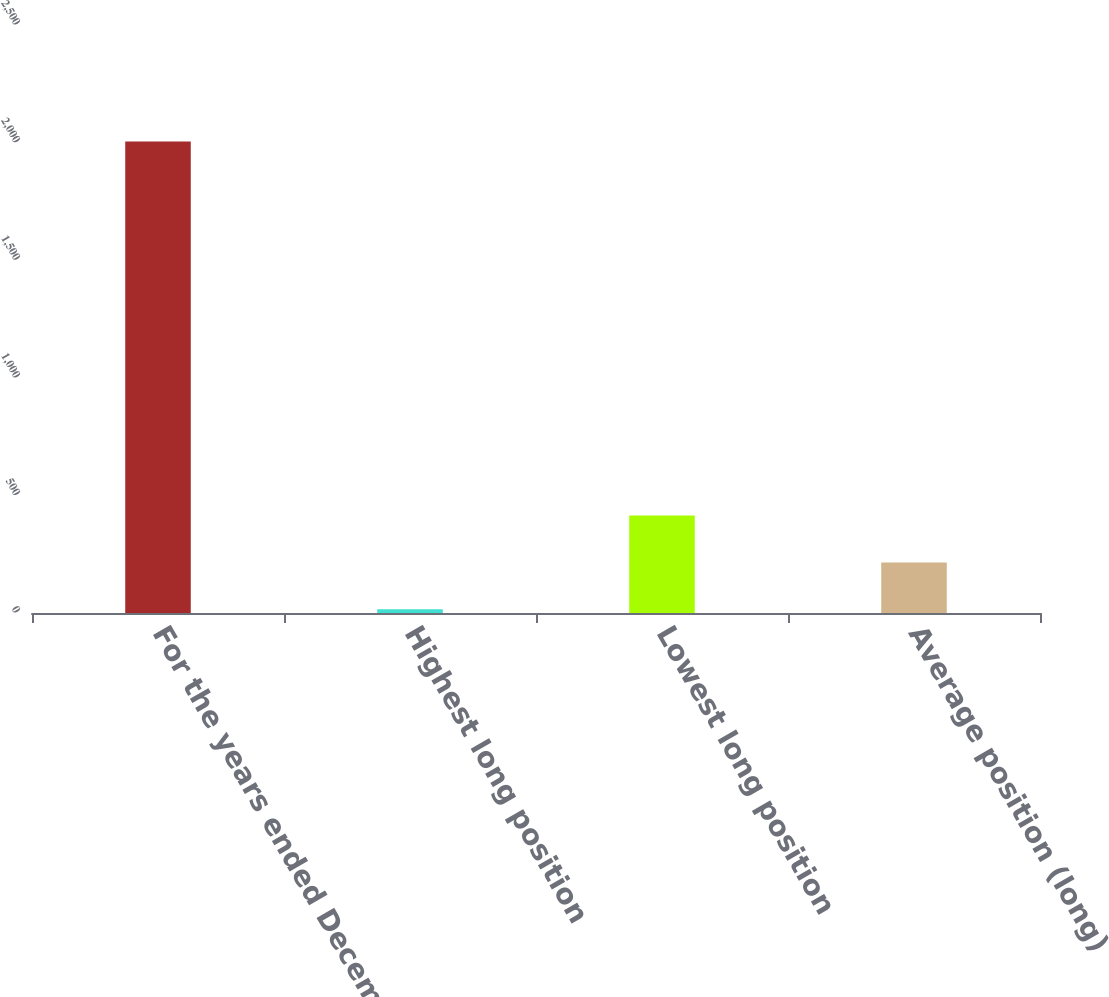Convert chart. <chart><loc_0><loc_0><loc_500><loc_500><bar_chart><fcel>For the years ended December<fcel>Highest long position<fcel>Lowest long position<fcel>Average position (long)<nl><fcel>2005<fcel>16.3<fcel>414.04<fcel>215.17<nl></chart> 